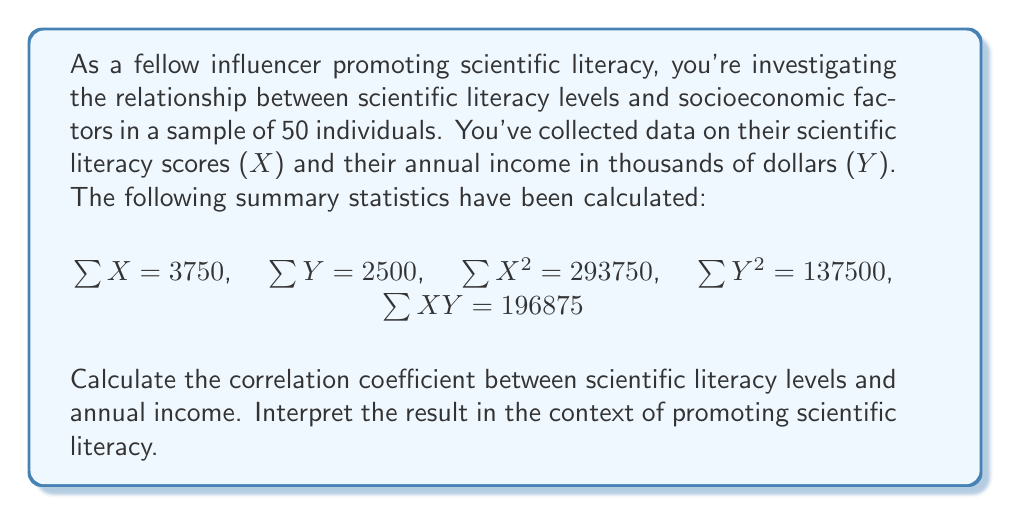What is the answer to this math problem? To calculate the correlation coefficient, we'll use the formula:

$$r = \frac{n\sum XY - \sum X \sum Y}{\sqrt{[n\sum X^2 - (\sum X)^2][n\sum Y^2 - (\sum Y)^2]}}$$

Where:
$n$ = number of individuals = 50
$\sum X$ = sum of scientific literacy scores = 3750
$\sum Y$ = sum of annual incomes = 2500
$\sum X^2$ = sum of squared scientific literacy scores = 293750
$\sum Y^2$ = sum of squared annual incomes = 137500
$\sum XY$ = sum of products of X and Y = 196875

Let's substitute these values into the formula:

$$r = \frac{50(196875) - (3750)(2500)}{\sqrt{[50(293750) - (3750)^2][50(137500) - (2500)^2]}}$$

$$r = \frac{9843750 - 9375000}{\sqrt{[14687500 - 14062500][6875000 - 6250000]}}$$

$$r = \frac{468750}{\sqrt{(625000)(625000)}}$$

$$r = \frac{468750}{625000}$$

$$r = 0.75$$

Interpretation: The correlation coefficient of 0.75 indicates a strong positive relationship between scientific literacy levels and annual income. This means that as scientific literacy increases, there tends to be an increase in annual income, and vice versa. However, it's important to note that correlation does not imply causation.

As an influencer promoting scientific literacy, this finding suggests that improving scientific literacy might be associated with better economic outcomes. It could be used to advocate for increased investment in science education and literacy programs, potentially leading to improved socioeconomic conditions. However, it's crucial to consider other factors that might influence this relationship and to conduct further research to establish any causal links.
Answer: The correlation coefficient between scientific literacy levels and annual income is 0.75, indicating a strong positive relationship. 